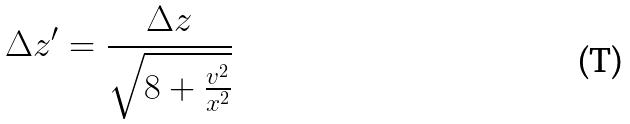<formula> <loc_0><loc_0><loc_500><loc_500>\Delta z ^ { \prime } = \frac { \Delta z } { \sqrt { 8 + \frac { v ^ { 2 } } { x ^ { 2 } } } }</formula> 